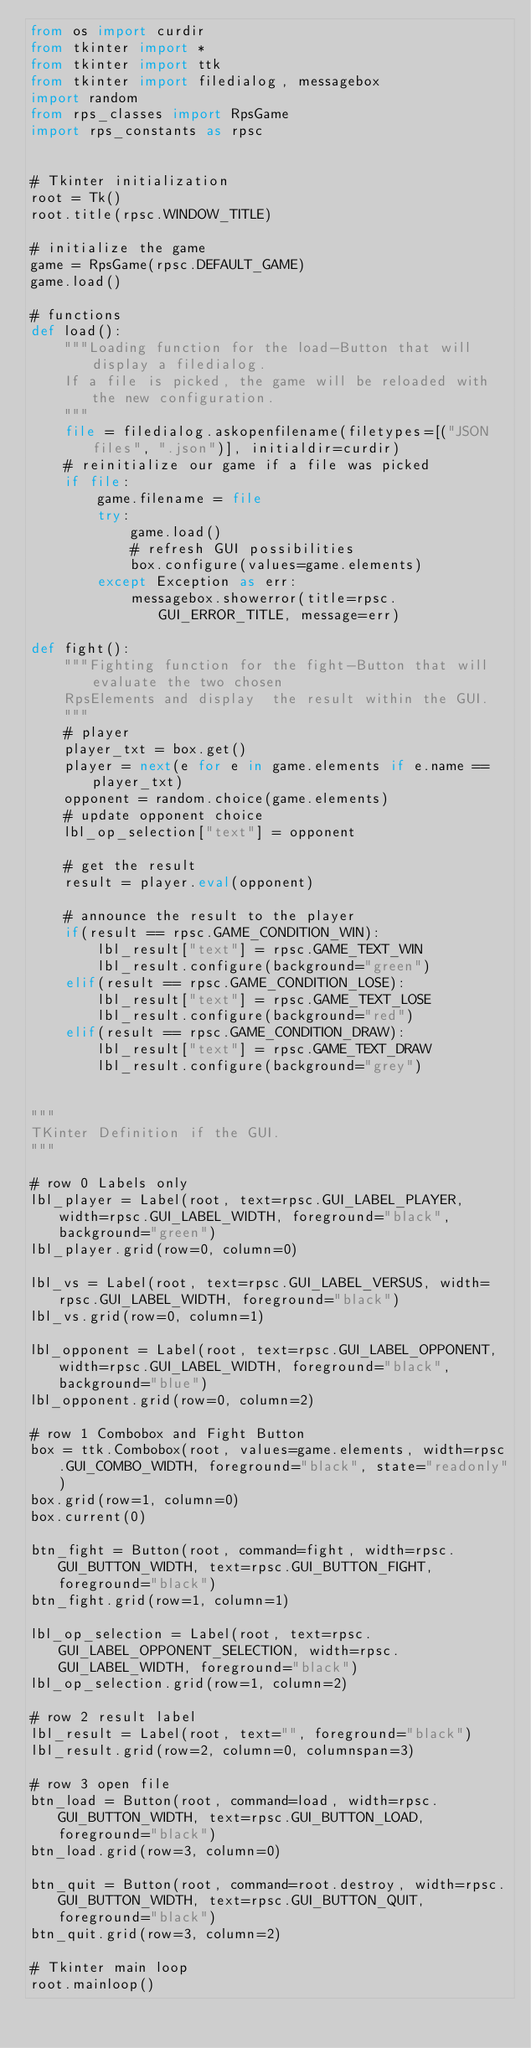<code> <loc_0><loc_0><loc_500><loc_500><_Python_>from os import curdir
from tkinter import *
from tkinter import ttk
from tkinter import filedialog, messagebox
import random
from rps_classes import RpsGame
import rps_constants as rpsc


# Tkinter initialization
root = Tk()
root.title(rpsc.WINDOW_TITLE)

# initialize the game
game = RpsGame(rpsc.DEFAULT_GAME)
game.load()

# functions
def load():
    """Loading function for the load-Button that will display a filedialog.
    If a file is picked, the game will be reloaded with the new configuration.
    """
    file = filedialog.askopenfilename(filetypes=[("JSON files", ".json")], initialdir=curdir)
    # reinitialize our game if a file was picked
    if file:
        game.filename = file
        try:
            game.load()
            # refresh GUI possibilities
            box.configure(values=game.elements)
        except Exception as err:
            messagebox.showerror(title=rpsc.GUI_ERROR_TITLE, message=err)

def fight():
    """Fighting function for the fight-Button that will evaluate the two chosen 
    RpsElements and display  the result within the GUI.
    """
    # player
    player_txt = box.get()
    player = next(e for e in game.elements if e.name == player_txt)
    opponent = random.choice(game.elements)
    # update opponent choice
    lbl_op_selection["text"] = opponent

    # get the result
    result = player.eval(opponent)

    # announce the result to the player
    if(result == rpsc.GAME_CONDITION_WIN):
        lbl_result["text"] = rpsc.GAME_TEXT_WIN
        lbl_result.configure(background="green")
    elif(result == rpsc.GAME_CONDITION_LOSE):
        lbl_result["text"] = rpsc.GAME_TEXT_LOSE
        lbl_result.configure(background="red")
    elif(result == rpsc.GAME_CONDITION_DRAW):
        lbl_result["text"] = rpsc.GAME_TEXT_DRAW
        lbl_result.configure(background="grey")


"""
TKinter Definition if the GUI.
"""

# row 0 Labels only
lbl_player = Label(root, text=rpsc.GUI_LABEL_PLAYER, width=rpsc.GUI_LABEL_WIDTH, foreground="black", background="green")
lbl_player.grid(row=0, column=0)

lbl_vs = Label(root, text=rpsc.GUI_LABEL_VERSUS, width=rpsc.GUI_LABEL_WIDTH, foreground="black")
lbl_vs.grid(row=0, column=1)

lbl_opponent = Label(root, text=rpsc.GUI_LABEL_OPPONENT, width=rpsc.GUI_LABEL_WIDTH, foreground="black", background="blue")
lbl_opponent.grid(row=0, column=2)

# row 1 Combobox and Fight Button
box = ttk.Combobox(root, values=game.elements, width=rpsc.GUI_COMBO_WIDTH, foreground="black", state="readonly")
box.grid(row=1, column=0)
box.current(0)

btn_fight = Button(root, command=fight, width=rpsc.GUI_BUTTON_WIDTH, text=rpsc.GUI_BUTTON_FIGHT, foreground="black")
btn_fight.grid(row=1, column=1)

lbl_op_selection = Label(root, text=rpsc.GUI_LABEL_OPPONENT_SELECTION, width=rpsc.GUI_LABEL_WIDTH, foreground="black")
lbl_op_selection.grid(row=1, column=2)

# row 2 result label
lbl_result = Label(root, text="", foreground="black")
lbl_result.grid(row=2, column=0, columnspan=3)

# row 3 open file
btn_load = Button(root, command=load, width=rpsc.GUI_BUTTON_WIDTH, text=rpsc.GUI_BUTTON_LOAD, foreground="black")
btn_load.grid(row=3, column=0)

btn_quit = Button(root, command=root.destroy, width=rpsc.GUI_BUTTON_WIDTH, text=rpsc.GUI_BUTTON_QUIT, foreground="black")
btn_quit.grid(row=3, column=2)

# Tkinter main loop
root.mainloop()</code> 